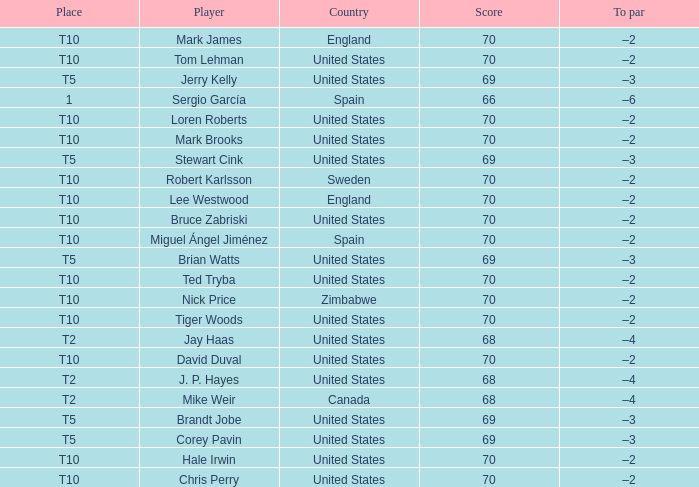What place did player mark brooks take? T10. 